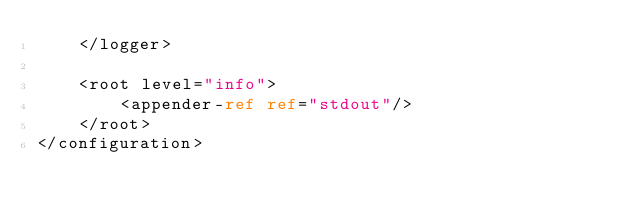<code> <loc_0><loc_0><loc_500><loc_500><_XML_>    </logger>

    <root level="info">
        <appender-ref ref="stdout"/>
    </root>
</configuration>
</code> 